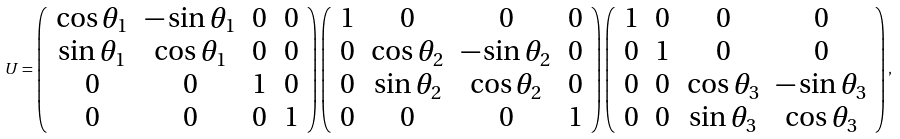<formula> <loc_0><loc_0><loc_500><loc_500>U = \left ( \begin{array} { c c c c } \cos \theta _ { 1 } & - \sin \theta _ { 1 } & 0 & 0 \\ \sin \theta _ { 1 } & \cos \theta _ { 1 } & 0 & 0 \\ 0 & 0 & 1 & 0 \\ 0 & 0 & 0 & 1 \end{array} \right ) \left ( \begin{array} { c c c c } 1 & 0 & 0 & 0 \\ 0 & \cos \theta _ { 2 } & - \sin \theta _ { 2 } & 0 \\ 0 & \sin \theta _ { 2 } & \cos \theta _ { 2 } & 0 \\ 0 & 0 & 0 & 1 \end{array} \right ) \left ( \begin{array} { c c c c } 1 & 0 & 0 & 0 \\ 0 & 1 & 0 & 0 \\ 0 & 0 & \cos \theta _ { 3 } & - \sin \theta _ { 3 } \\ 0 & 0 & \sin \theta _ { 3 } & \cos \theta _ { 3 } \end{array} \right ) ,</formula> 